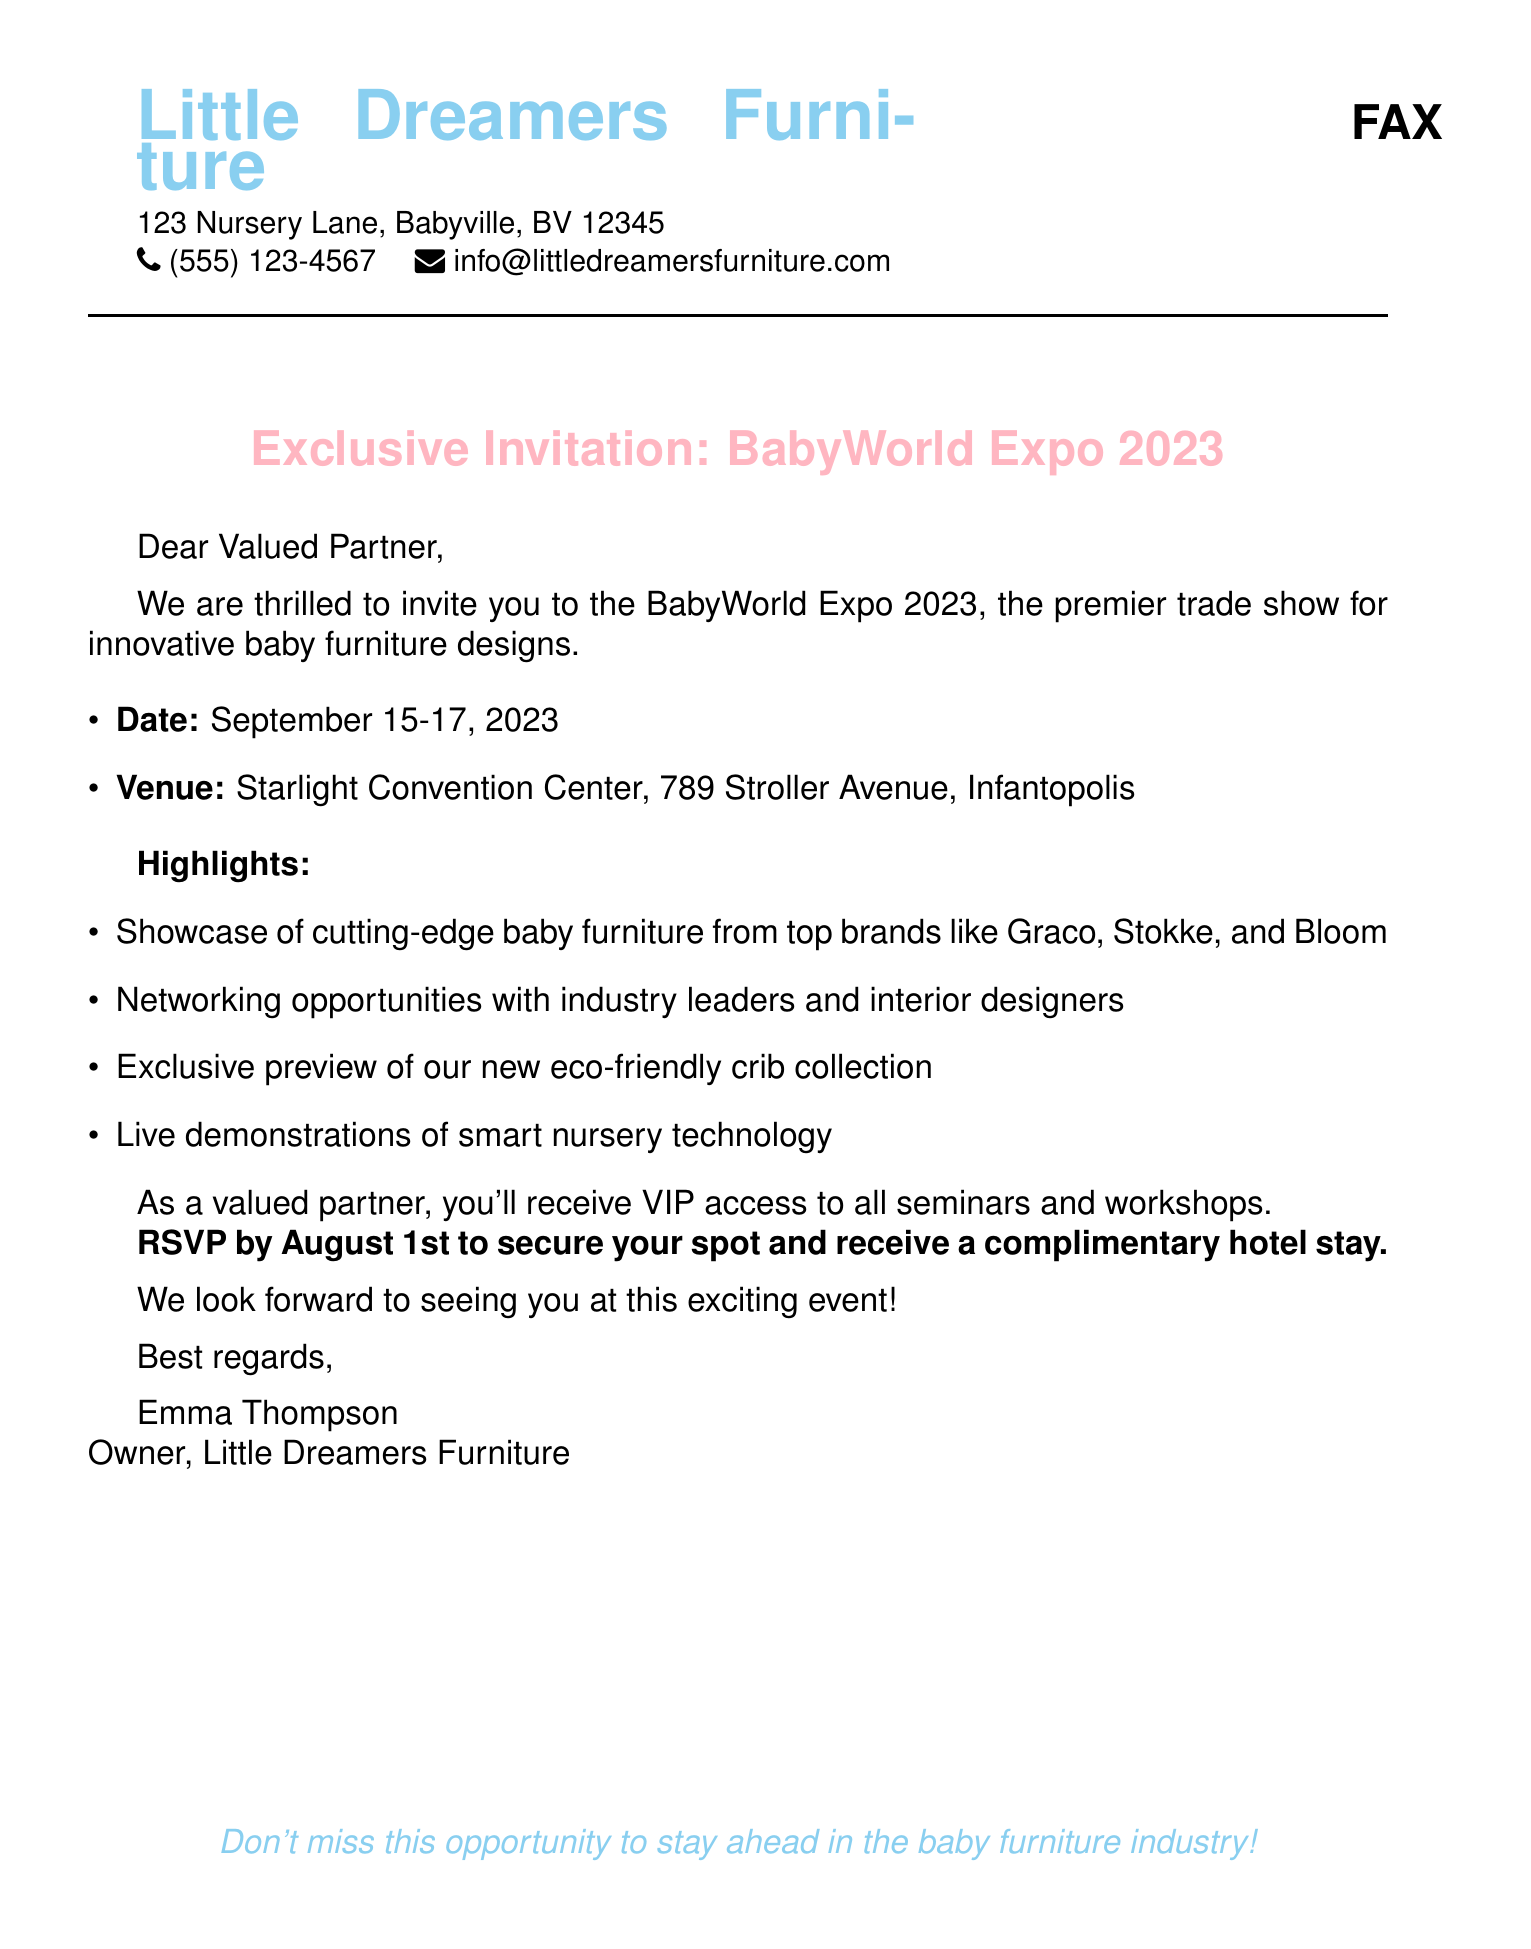What is the event name? The document specifies the name of the event as BabyWorld Expo 2023.
Answer: BabyWorld Expo 2023 What are the dates of the event? The event is scheduled to take place from September 15-17, 2023.
Answer: September 15-17, 2023 Where is the venue located? The document states that the venue is Starlight Convention Center, located at 789 Stroller Avenue, Infantopolis.
Answer: Starlight Convention Center, 789 Stroller Avenue, Infantopolis What is included with the RSVP by August 1st? The document mentions that a complimentary hotel stay is offered to those who RSVP by August 1st.
Answer: Complimentary hotel stay Who is the sender of the invitation? The invitation is sent by Emma Thompson, the owner of Little Dreamers Furniture.
Answer: Emma Thompson What type of access will attendees receive? Attendees will receive VIP access to all seminars and workshops at the event.
Answer: VIP access Which brands will showcase at the event? The document lists Graco, Stokke, and Bloom as top brands showcasing their products.
Answer: Graco, Stokke, Bloom What is a highlight of the event? The event highlights include an exclusive preview of a new eco-friendly crib collection.
Answer: Exclusive preview of eco-friendly crib collection What opportunity is available for networking? The document mentions networking opportunities with industry leaders and interior designers.
Answer: Networking opportunities with industry leaders and interior designers 